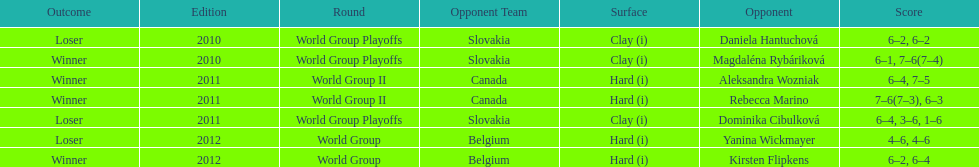Number of games in the match against dominika cibulkova? 3. 